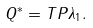Convert formula to latex. <formula><loc_0><loc_0><loc_500><loc_500>Q ^ { * } = T P \lambda _ { 1 } .</formula> 